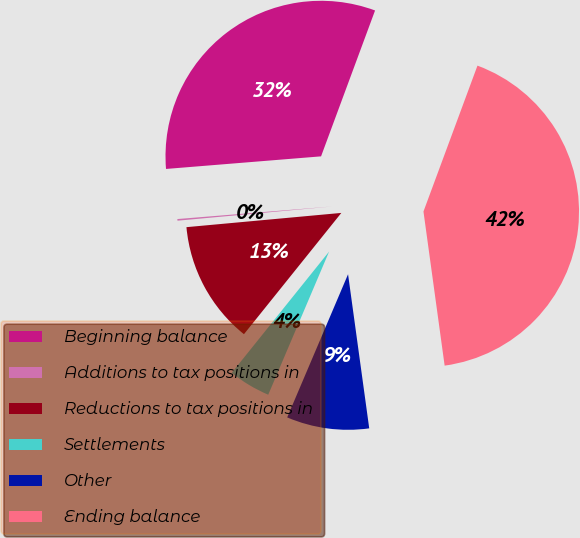Convert chart to OTSL. <chart><loc_0><loc_0><loc_500><loc_500><pie_chart><fcel>Beginning balance<fcel>Additions to tax positions in<fcel>Reductions to tax positions in<fcel>Settlements<fcel>Other<fcel>Ending balance<nl><fcel>31.93%<fcel>0.17%<fcel>12.77%<fcel>4.37%<fcel>8.57%<fcel>42.18%<nl></chart> 